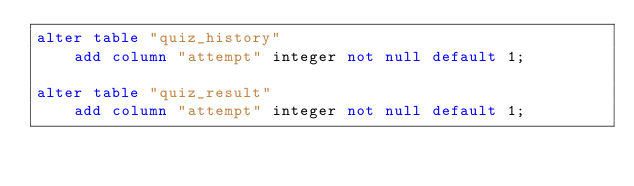Convert code to text. <code><loc_0><loc_0><loc_500><loc_500><_SQL_>alter table "quiz_history"
    add column "attempt" integer not null default 1;

alter table "quiz_result"
    add column "attempt" integer not null default 1;</code> 